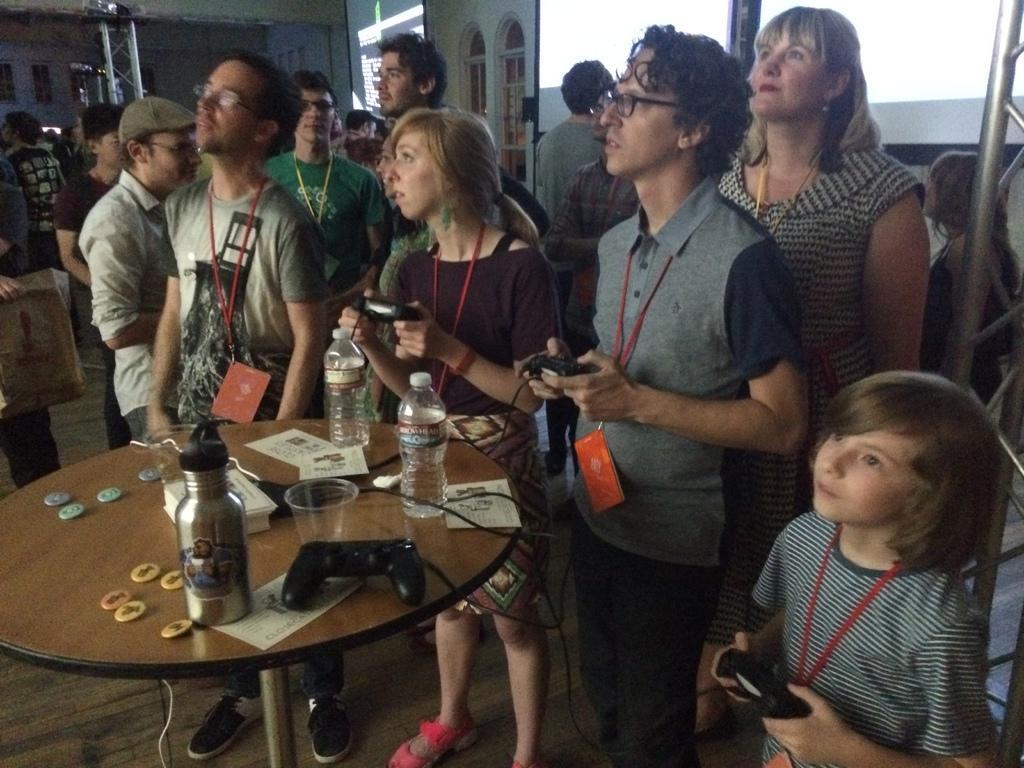Could you give a brief overview of what you see in this image? In this image there are group of people who are standing it seems that they are playing video games, in front of them there is one table. On the table there is one bottle, cups and some cards are there on the top there is a window. 